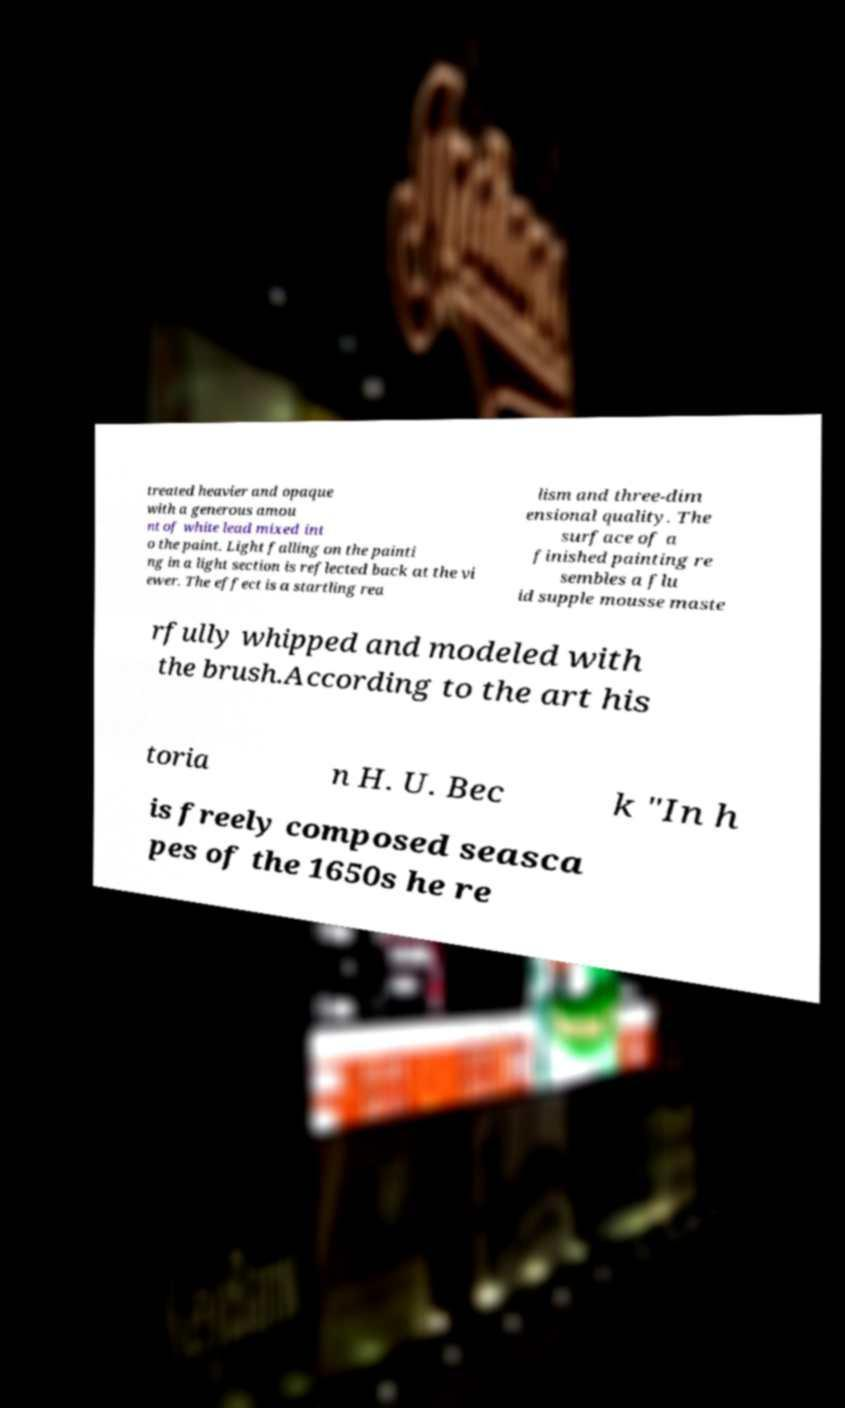What messages or text are displayed in this image? I need them in a readable, typed format. treated heavier and opaque with a generous amou nt of white lead mixed int o the paint. Light falling on the painti ng in a light section is reflected back at the vi ewer. The effect is a startling rea lism and three-dim ensional quality. The surface of a finished painting re sembles a flu id supple mousse maste rfully whipped and modeled with the brush.According to the art his toria n H. U. Bec k "In h is freely composed seasca pes of the 1650s he re 